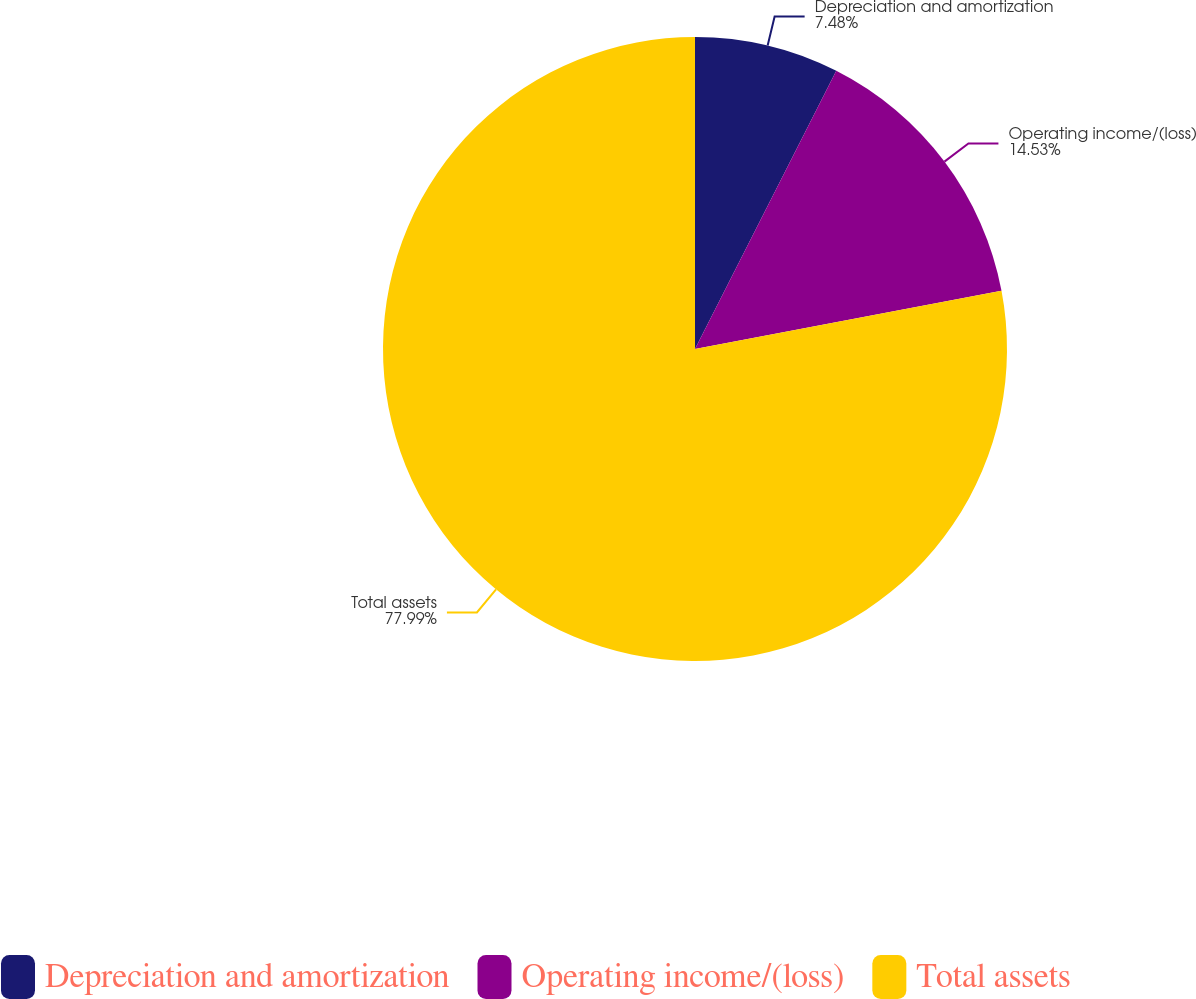Convert chart. <chart><loc_0><loc_0><loc_500><loc_500><pie_chart><fcel>Depreciation and amortization<fcel>Operating income/(loss)<fcel>Total assets<nl><fcel>7.48%<fcel>14.53%<fcel>77.99%<nl></chart> 